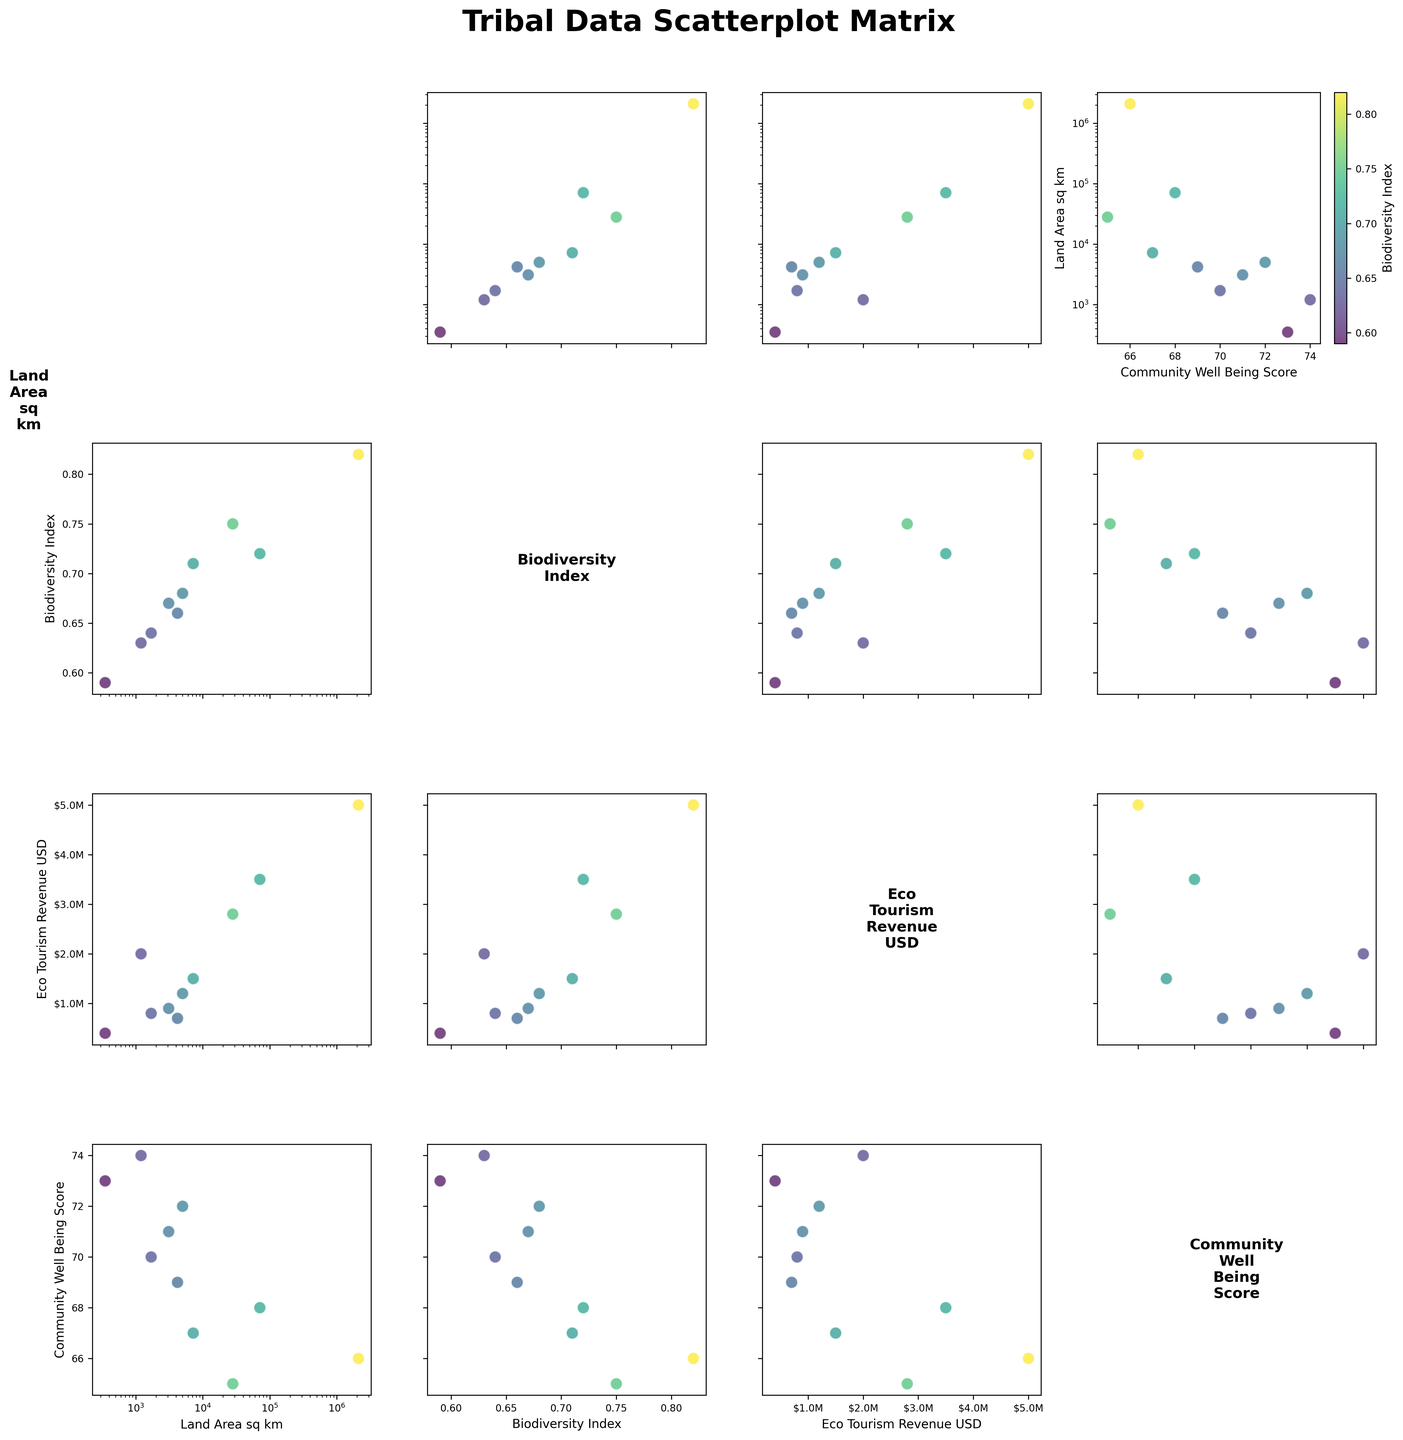What is the title of the scatterplot matrix? The title is found at the top of the figure and gives a summary of what the figure represents.
Answer: Tribal Data Scatterplot Matrix Which tribe has the largest land area according to the scatterplot matrix? Larger values on the "Land Area (sq km)" axis indicate larger land areas. Locate the highest point on the "Land Area (sq km)" axis.
Answer: Inuit How does the Biodiversity Index correlate with the Community Well-Being Score for the Navajo tribe? Find the position of the Navajo tribe on the scatterplot matrix specifically for the Biodiversity Index vs. Community Well-Being Score. Check if the points are close to establishing a positive or negative trend.
Answer: Some positive correlation Which tribe generates the highest Eco-Tourism revenue, and what is their Biodiversity Index? Locate the highest point on the "Eco-Tourism Revenue (USD)" axis, then check the corresponding Biodiversity Index using the color bar.
Answer: Inuit, 0.82 What can you say about the relationship between Land Area and Eco-Tourism Revenue across different tribes? Observe the pattern and spread of points in the scatterplots comparing "Land Area" with "Eco-Tourism Revenue". Look for trends or correlations.
Answer: Larger land areas tend to have higher Eco-Tourism Revenue Do tribes with higher Community Well-Being Scores generally have higher or lower Biodiversity Indexes? Compare the points in the scatterplots of Biodiversity Index vs. Community Well-Being Scores. Look for general trends in the distribution of points.
Answer: Higher Community Well-Being Scores correlate with somewhat lower Biodiversity Indexes Which tribe combines both a high Biodiversity Index and a high Community Well-Being Score? Look for points that are high on both the "Biodiversity Index" and "Community Well-Being Score" axes. Identify corresponding tribe names.
Answer: Seminole Are there any visible outliers in terms of Land Area vs. Biodiversity Index? Identify points that are far removed from the general trend in the scatterplot of Land Area vs. Biodiversity Index.
Answer: Inuit What is the general trend between Land Area and Community Well-Being Score? Observe the scatterplot of "Land Area" vs. "Community Well-Being Score". Look for a positive, negative, or no observable trend.
Answer: No clear trend 